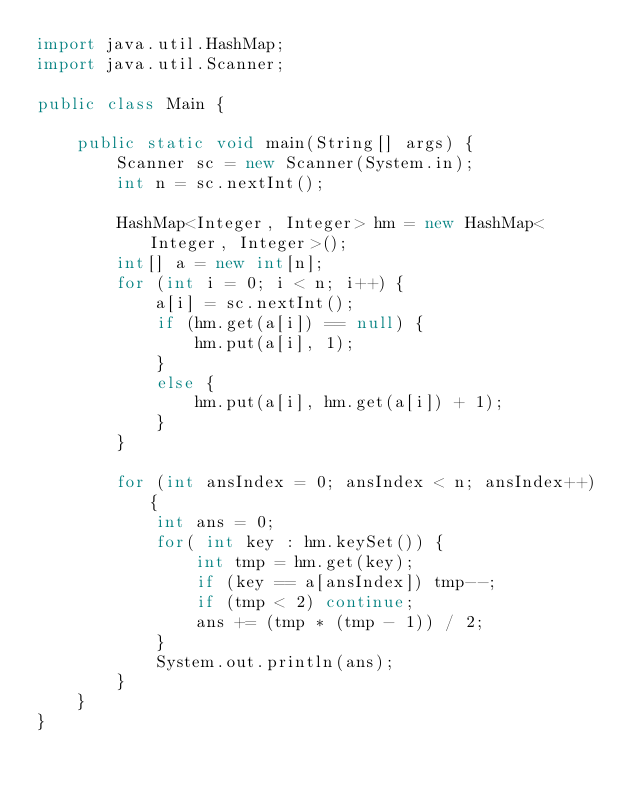Convert code to text. <code><loc_0><loc_0><loc_500><loc_500><_Java_>import java.util.HashMap;
import java.util.Scanner;

public class Main {

    public static void main(String[] args) {
        Scanner sc = new Scanner(System.in);
        int n = sc.nextInt();

        HashMap<Integer, Integer> hm = new HashMap<Integer, Integer>();
        int[] a = new int[n];
        for (int i = 0; i < n; i++) {
            a[i] = sc.nextInt();
            if (hm.get(a[i]) == null) {
                hm.put(a[i], 1);
            }
            else {
                hm.put(a[i], hm.get(a[i]) + 1);
            }
        }

        for (int ansIndex = 0; ansIndex < n; ansIndex++) {
            int ans = 0;
            for( int key : hm.keySet()) {
                int tmp = hm.get(key);
                if (key == a[ansIndex]) tmp--;
                if (tmp < 2) continue;
                ans += (tmp * (tmp - 1)) / 2;
            }
            System.out.println(ans);
        }
    }
}</code> 